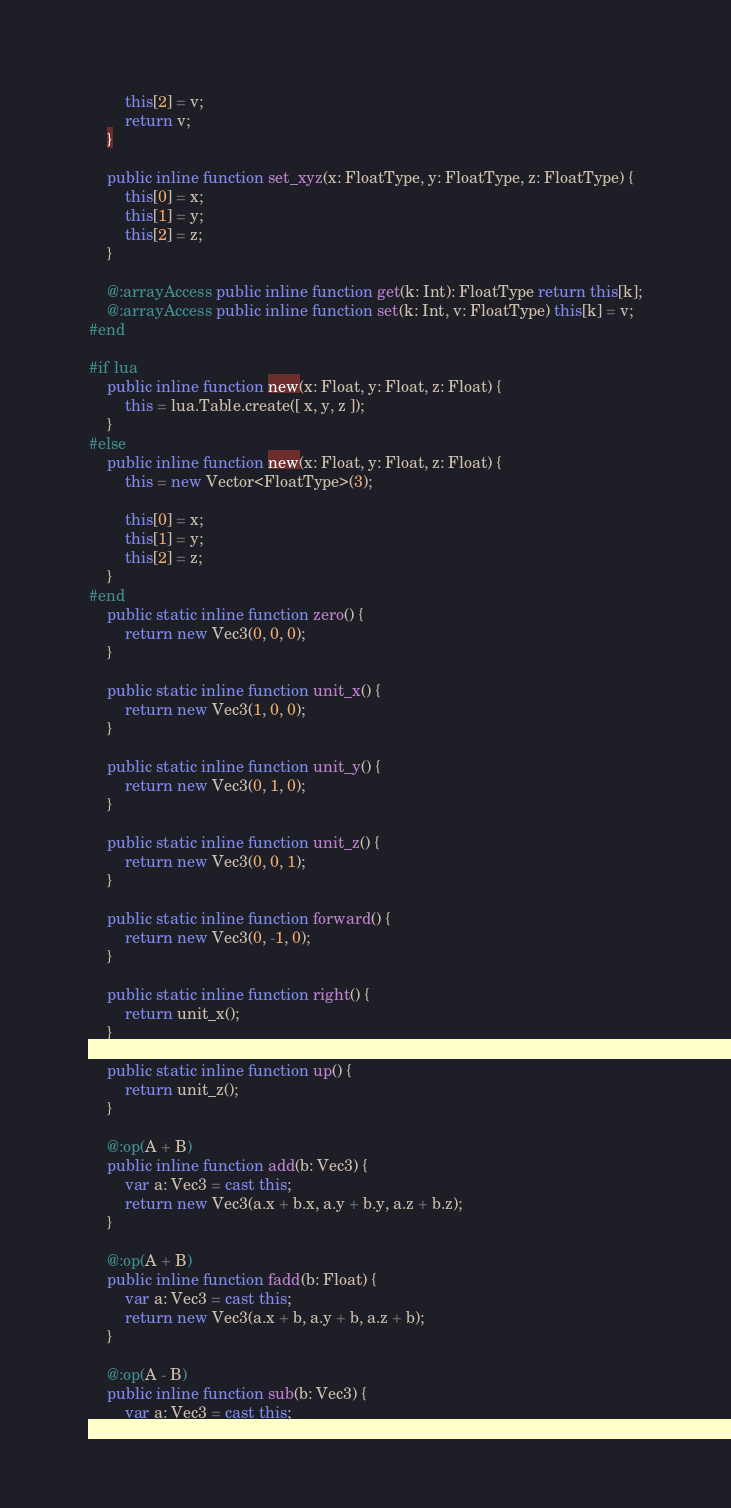Convert code to text. <code><loc_0><loc_0><loc_500><loc_500><_Haxe_>		this[2] = v;
		return v;
	}

	public inline function set_xyz(x: FloatType, y: FloatType, z: FloatType) {
		this[0] = x;
		this[1] = y;
		this[2] = z;
	}

	@:arrayAccess public inline function get(k: Int): FloatType return this[k];
	@:arrayAccess public inline function set(k: Int, v: FloatType) this[k] = v;
#end

#if lua
	public inline function new(x: Float, y: Float, z: Float) {
		this = lua.Table.create([ x, y, z ]);
	}
#else
	public inline function new(x: Float, y: Float, z: Float) {
		this = new Vector<FloatType>(3);

		this[0] = x;
		this[1] = y;
		this[2] = z;
	}
#end
	public static inline function zero() {
		return new Vec3(0, 0, 0);
	}

	public static inline function unit_x() {
		return new Vec3(1, 0, 0);
	}

	public static inline function unit_y() {
		return new Vec3(0, 1, 0);
	}

	public static inline function unit_z() {
		return new Vec3(0, 0, 1);
	}

	public static inline function forward() {
		return new Vec3(0, -1, 0);
	}

	public static inline function right() {
		return unit_x();
	}

	public static inline function up() {
		return unit_z();
	}

	@:op(A + B)
	public inline function add(b: Vec3) {
		var a: Vec3 = cast this;
		return new Vec3(a.x + b.x, a.y + b.y, a.z + b.z);
	}

	@:op(A + B)
	public inline function fadd(b: Float) {
		var a: Vec3 = cast this;
		return new Vec3(a.x + b, a.y + b, a.z + b);
	}

	@:op(A - B)
	public inline function sub(b: Vec3) {
		var a: Vec3 = cast this;</code> 